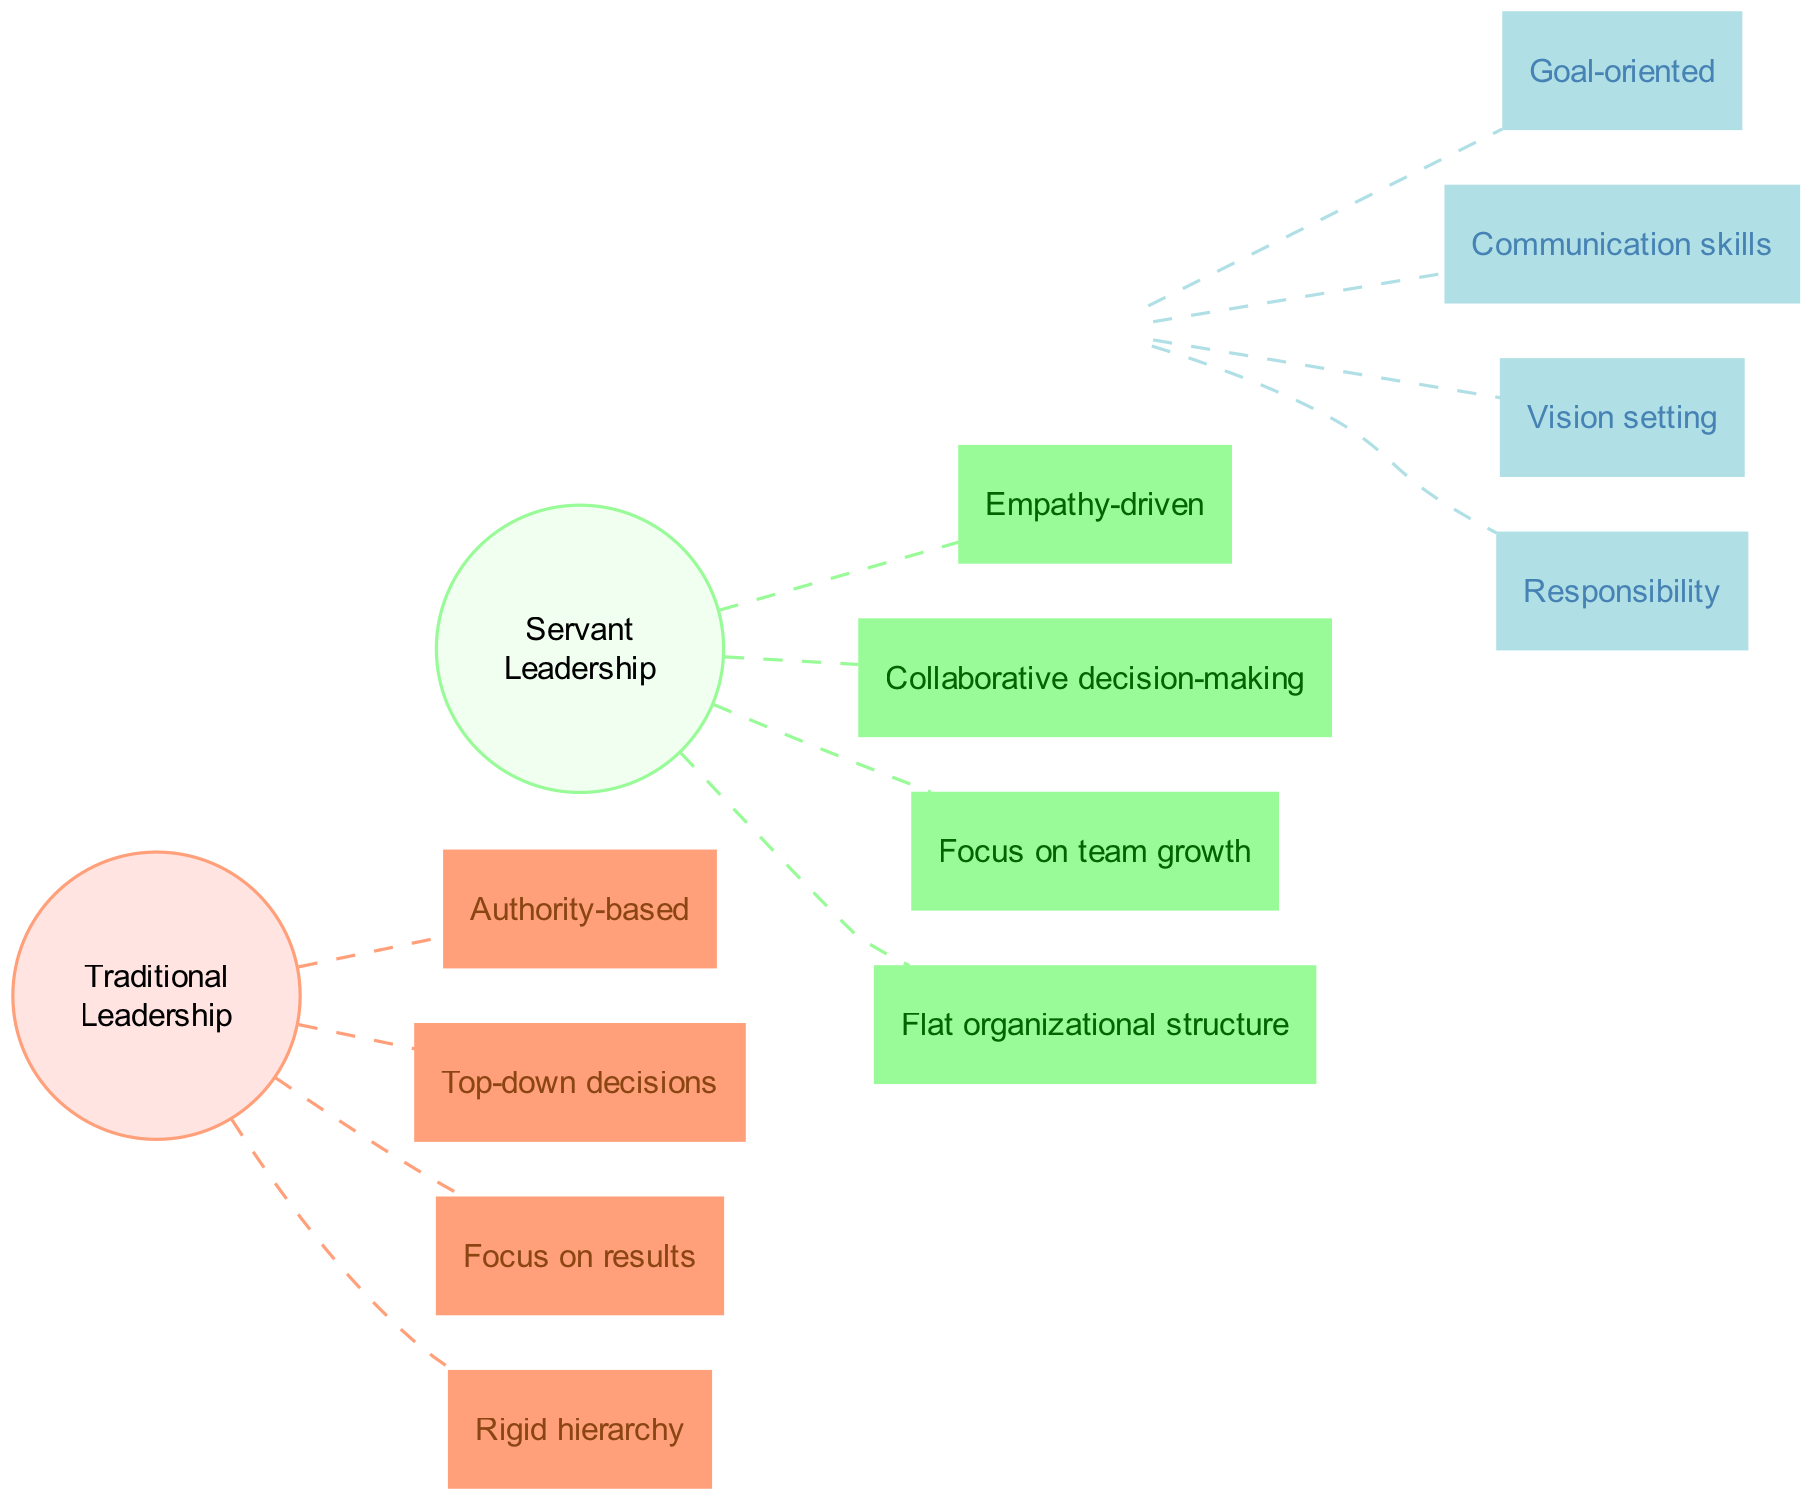What are the two main leadership styles compared in the diagram? The diagram specifically highlights "Traditional Leadership" and "Servant Leadership" as the two main leadership styles, as represented by the two different colored nodes on either side.
Answer: Traditional Leadership, Servant Leadership How many principles are there for Traditional Leadership? By counting the box nodes connected to the "Traditional Leadership" node, there are four principles listed within the diagram.
Answer: 4 What principle is shared between Traditional Leadership and Servant Leadership? The shared principle can be identified by observing the overlapping section of the Venn diagram and noting at least one of the listed shared principles, which are represented in a separate color.
Answer: Goal-oriented, Communication skills, Vision setting, Responsibility Which leadership style focuses on empathy? Examining the principles associated with each leadership style, "Empathy-driven" is clearly listed under "Servant Leadership," indicating that this style emphasizes empathy in its approach.
Answer: Servant Leadership How does the decision-making approach differ between the two leadership styles? Evaluating both sides of the Venn diagram, "Top-down decisions" is associated with "Traditional Leadership," while "Collaborative decision-making" is listed under "Servant Leadership," showing the contrasting approaches to decision-making.
Answer: Traditional Leadership, Servant Leadership What color represents the Servant Leadership node? The Servant Leadership node is depicted in a soft green color (#98FB98) in the diagram, making it visually distinct from the other leadership style.
Answer: Soft green What is the relationship between Communication skills and shared principles? "Communication skills" is one of the principles listed in the shared section of the Venn diagram, which indicates that both leadership styles value this competency in different contexts.
Answer: Communication skills Which leadership style has a rigid hierarchy? The "Rigid hierarchy" principle is specifically associated with "Traditional Leadership," emphasizing a structured and authoritative approach in contrast to Servant Leadership.
Answer: Traditional Leadership 